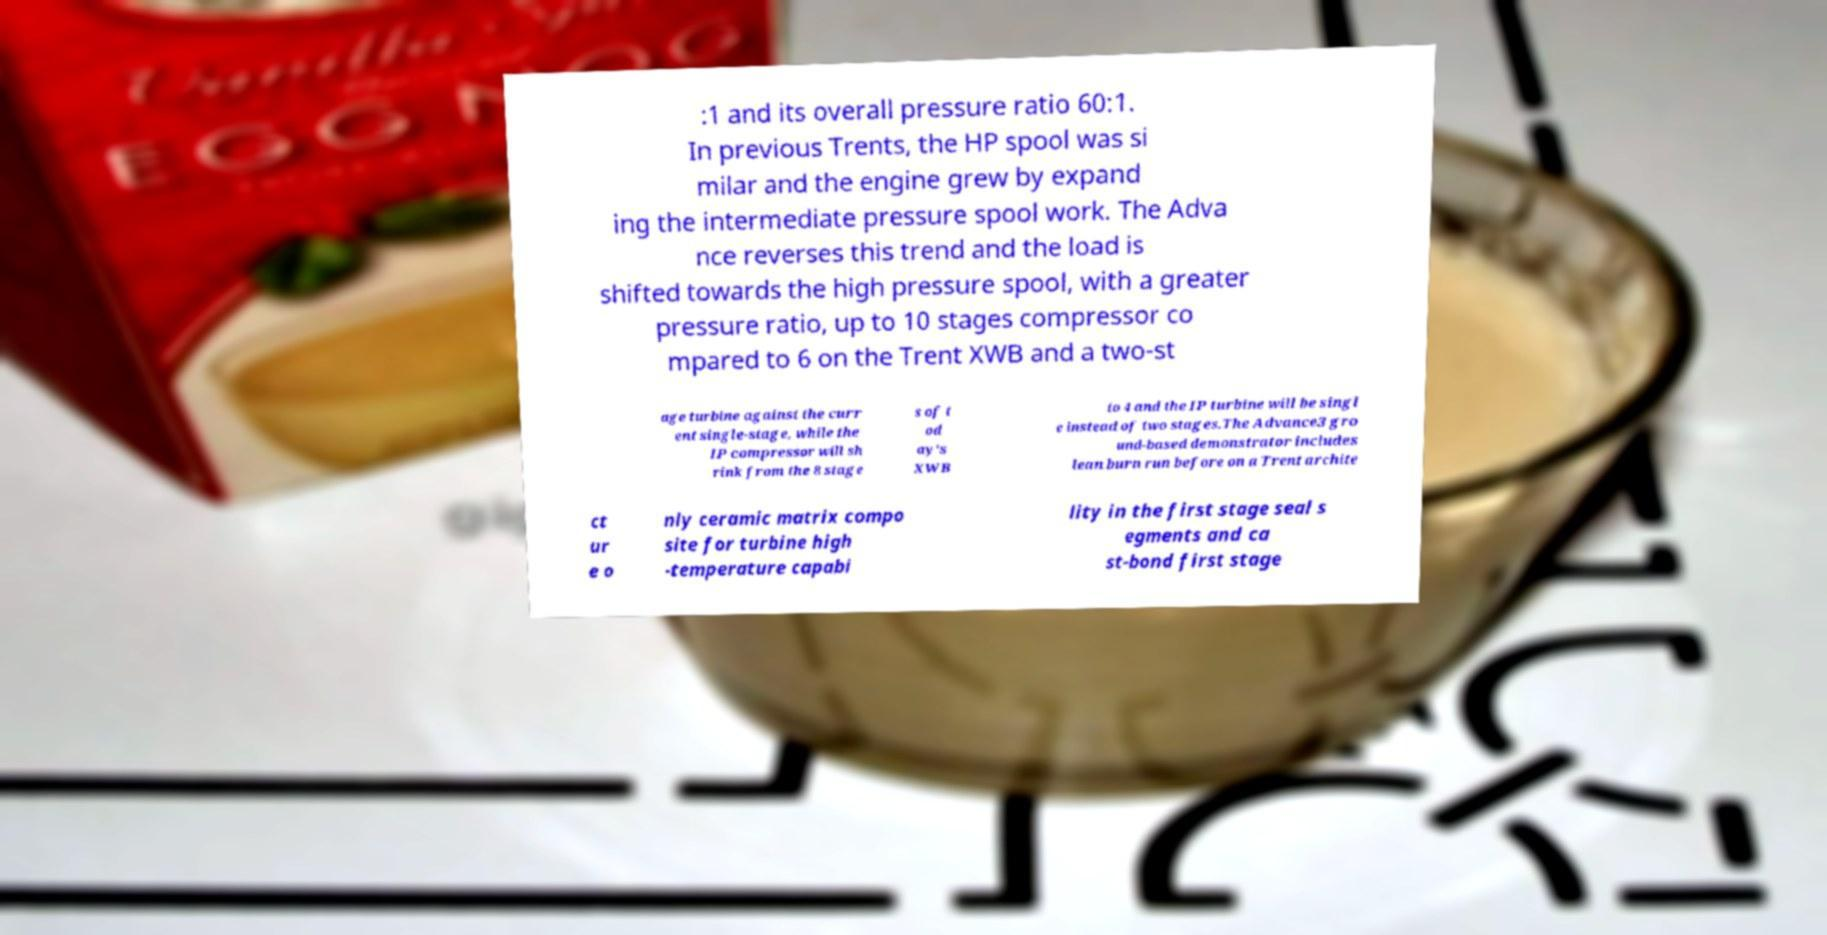Could you extract and type out the text from this image? :1 and its overall pressure ratio 60:1. In previous Trents, the HP spool was si milar and the engine grew by expand ing the intermediate pressure spool work. The Adva nce reverses this trend and the load is shifted towards the high pressure spool, with a greater pressure ratio, up to 10 stages compressor co mpared to 6 on the Trent XWB and a two-st age turbine against the curr ent single-stage, while the IP compressor will sh rink from the 8 stage s of t od ay's XWB to 4 and the IP turbine will be singl e instead of two stages.The Advance3 gro und-based demonstrator includes lean burn run before on a Trent archite ct ur e o nly ceramic matrix compo site for turbine high -temperature capabi lity in the first stage seal s egments and ca st-bond first stage 